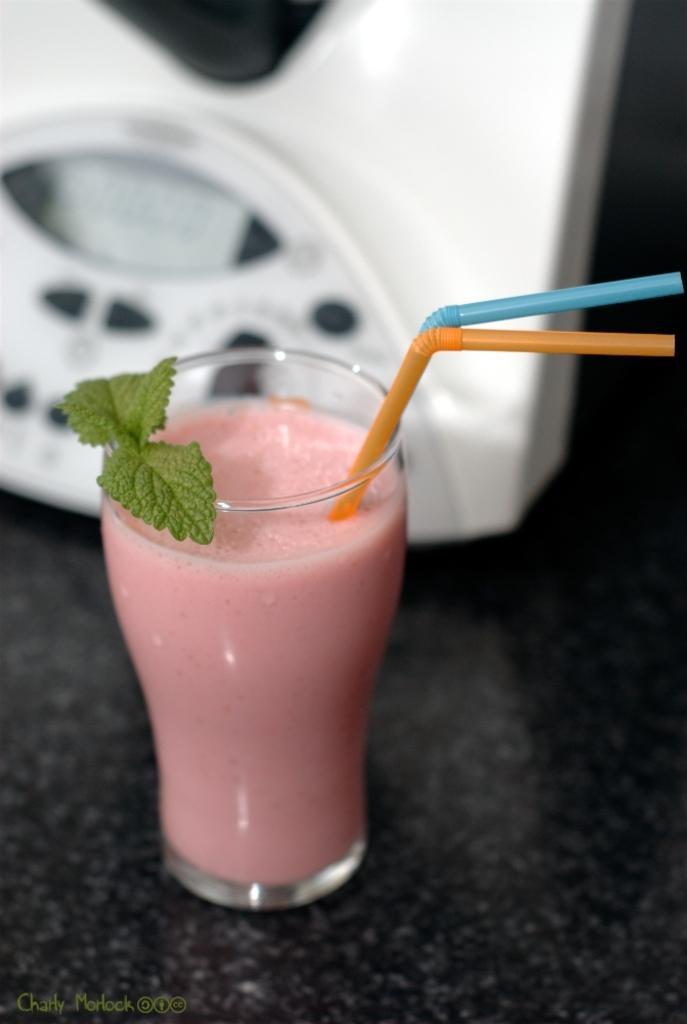How would you summarize this image in a sentence or two? In this image I see the glass in which there is pink color liquid and I see 2 straws and I see green leaves over here and I see the black color surface and I see the watermark over here. In the background I see the white and black color electronic device over here. 